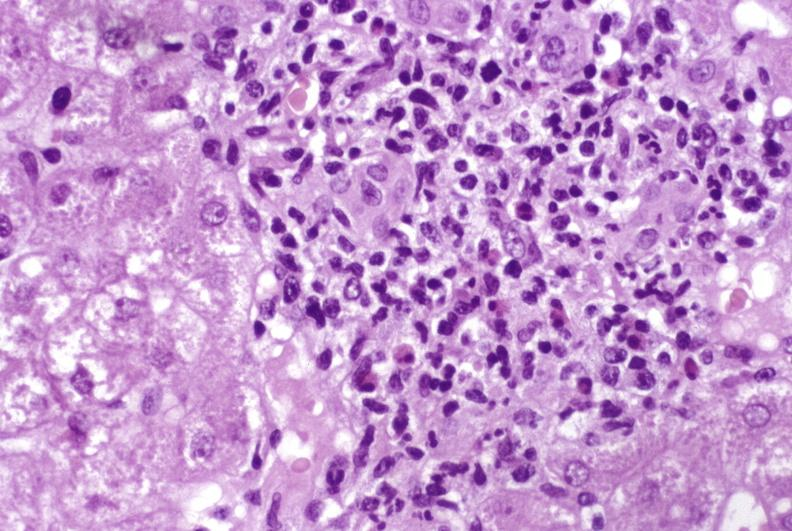s hepatobiliary present?
Answer the question using a single word or phrase. Yes 